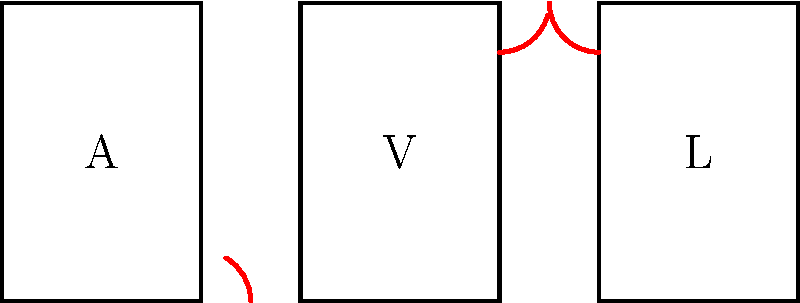As a book editor with a keen eye for typography, analyze the angles formed in the letters A, V, and L shown above. Identify which type of angle (acute, obtuse, or right) is highlighted in red for each letter. Let's analyze each letter step-by-step:

1. Letter A:
   - The highlighted angle is formed by the left leg and the horizontal stroke.
   - This angle is clearly less than 90°.
   - Therefore, it is an acute angle.

2. Letter V:
   - The highlighted angle is formed by the right leg and an imaginary horizontal line.
   - This angle is visibly greater than 90°.
   - Thus, it is an obtuse angle.

3. Letter L:
   - The highlighted angle is formed by the vertical stroke and the horizontal base.
   - This angle appears to be exactly 90°.
   - Therefore, it is a right angle.

In typography, these angle types play crucial roles in letterform design:
- Acute angles (like in A) often create sharp, dynamic forms.
- Obtuse angles (like in V) can add a sense of openness or expansion.
- Right angles (like in L) provide structure and balance to letterforms.

Understanding these angles helps in maintaining consistency and legibility across different typefaces.
Answer: A: Acute, V: Obtuse, L: Right 